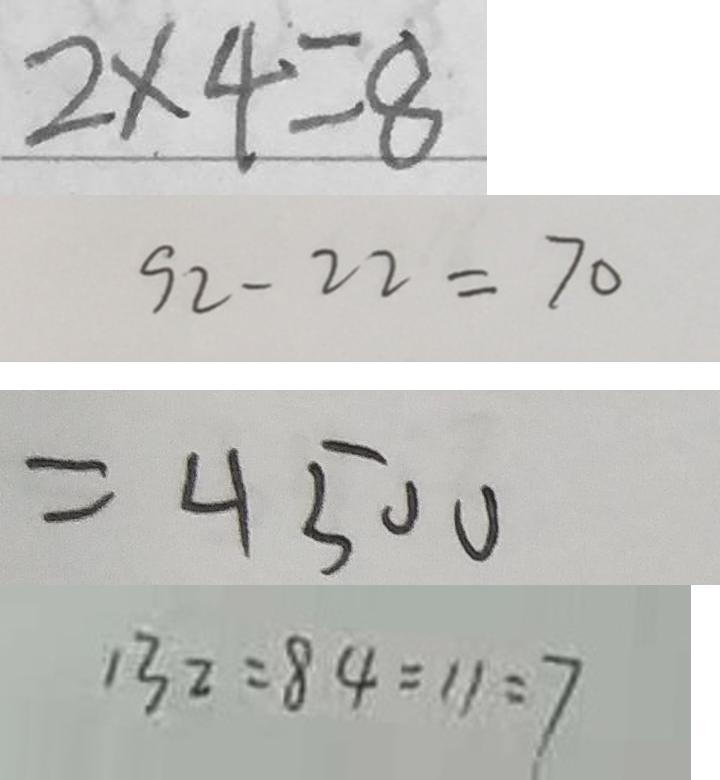Convert formula to latex. <formula><loc_0><loc_0><loc_500><loc_500>2 \times 4 = 8 
 9 2 - 2 2 = 7 0 
 = 4 5 0 0 
 1 3 2 : 8 4 = 1 1 : 7</formula> 